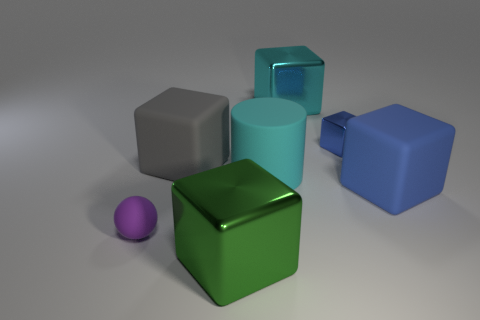How would the scene change if the background color was dark instead of light? With a dark background, the objects would be more visually prominent, with the shiny surfaces potentially reflecting less light. Shadows might be less noticeable, and the overall contrast would give the image a different mood, possibly making it appear more dramatic. 